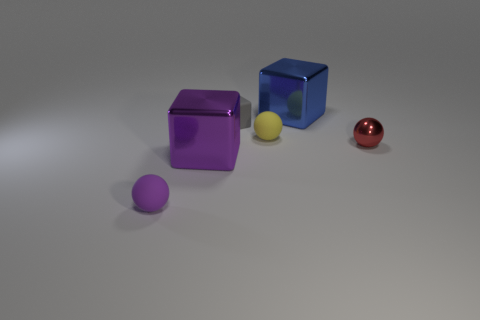What is the color of the block that is in front of the red shiny thing?
Offer a very short reply. Purple. Are the large object that is behind the small red thing and the small red thing made of the same material?
Make the answer very short. Yes. How many small things are both to the left of the large blue block and to the right of the small purple sphere?
Provide a short and direct response. 2. What color is the metal ball that is right of the rubber ball left of the metallic cube that is in front of the matte cube?
Your response must be concise. Red. There is a large purple thing that is left of the large blue shiny thing; is there a big thing that is right of it?
Your response must be concise. Yes. How many matte things are either tiny red cubes or big blue cubes?
Provide a succinct answer. 0. There is a thing that is both on the right side of the yellow matte sphere and behind the tiny red shiny thing; what material is it?
Make the answer very short. Metal. Are there any tiny objects on the left side of the metal block behind the purple thing behind the purple matte thing?
Offer a terse response. Yes. There is a small object that is made of the same material as the blue cube; what shape is it?
Your answer should be very brief. Sphere. Is the number of big purple things that are behind the large blue cube less than the number of small yellow spheres that are on the left side of the big purple metallic cube?
Offer a very short reply. No. 